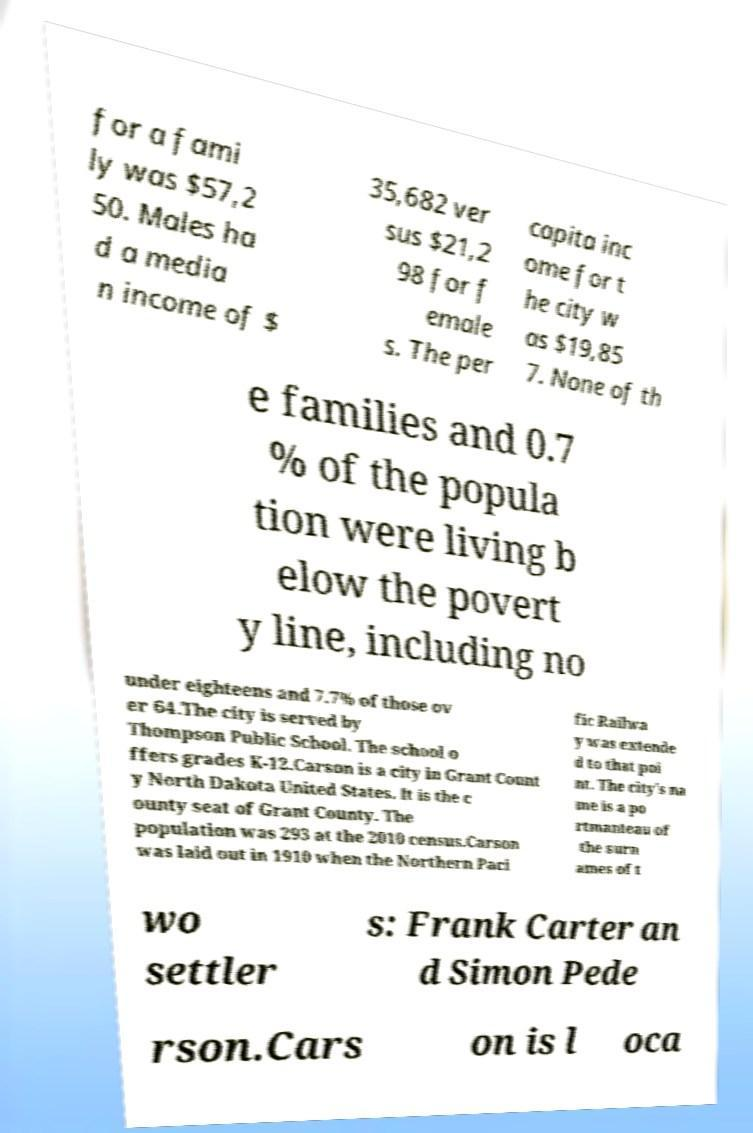There's text embedded in this image that I need extracted. Can you transcribe it verbatim? for a fami ly was $57,2 50. Males ha d a media n income of $ 35,682 ver sus $21,2 98 for f emale s. The per capita inc ome for t he city w as $19,85 7. None of th e families and 0.7 % of the popula tion were living b elow the povert y line, including no under eighteens and 7.7% of those ov er 64.The city is served by Thompson Public School. The school o ffers grades K-12.Carson is a city in Grant Count y North Dakota United States. It is the c ounty seat of Grant County. The population was 293 at the 2010 census.Carson was laid out in 1910 when the Northern Paci fic Railwa y was extende d to that poi nt. The city's na me is a po rtmanteau of the surn ames of t wo settler s: Frank Carter an d Simon Pede rson.Cars on is l oca 